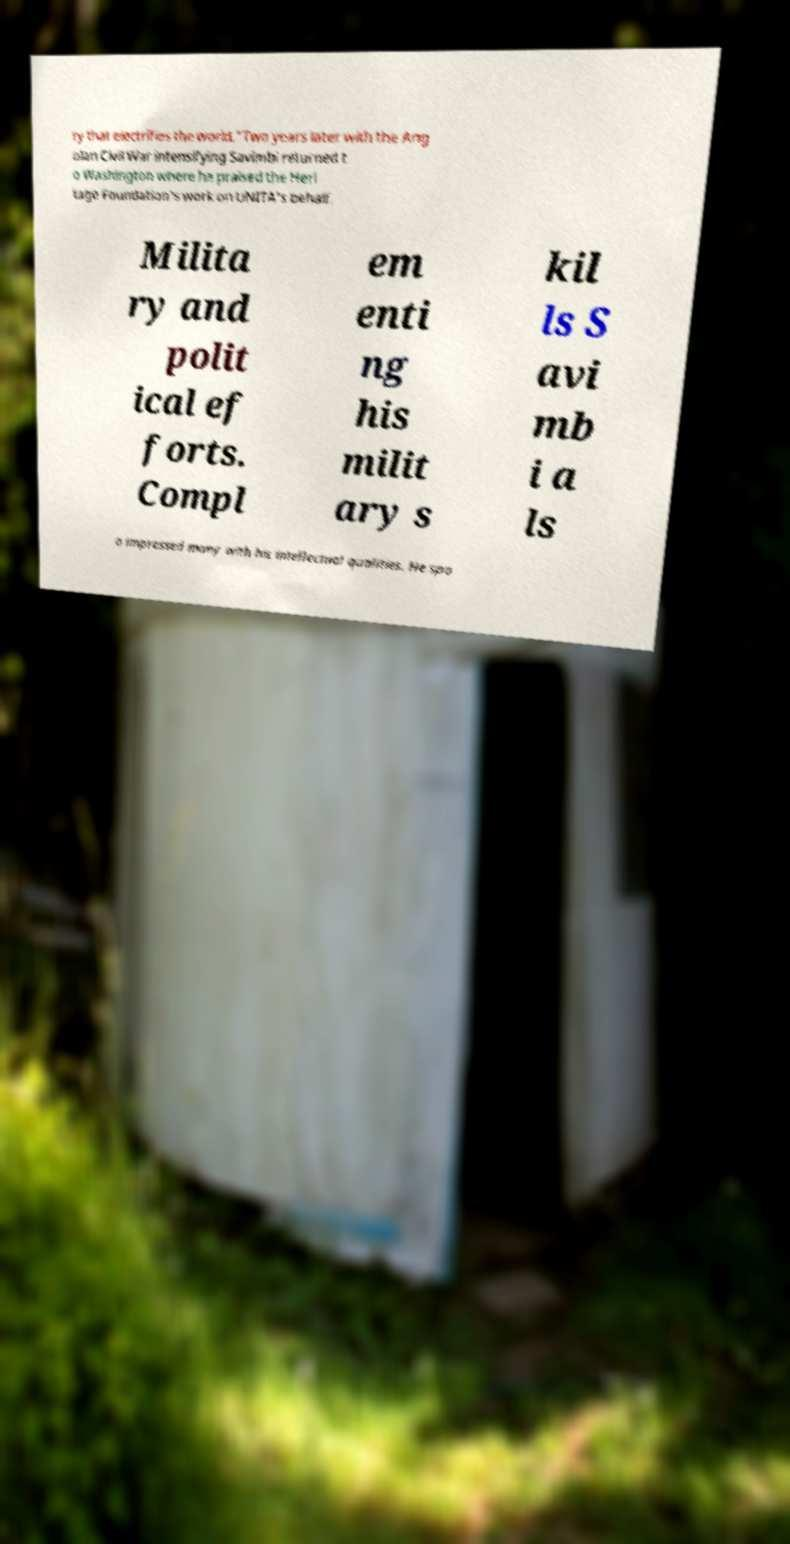Please identify and transcribe the text found in this image. ry that electrifies the world."Two years later with the Ang olan Civil War intensifying Savimbi returned t o Washington where he praised the Heri tage Foundation's work on UNITA's behalf. Milita ry and polit ical ef forts. Compl em enti ng his milit ary s kil ls S avi mb i a ls o impressed many with his intellectual qualities. He spo 